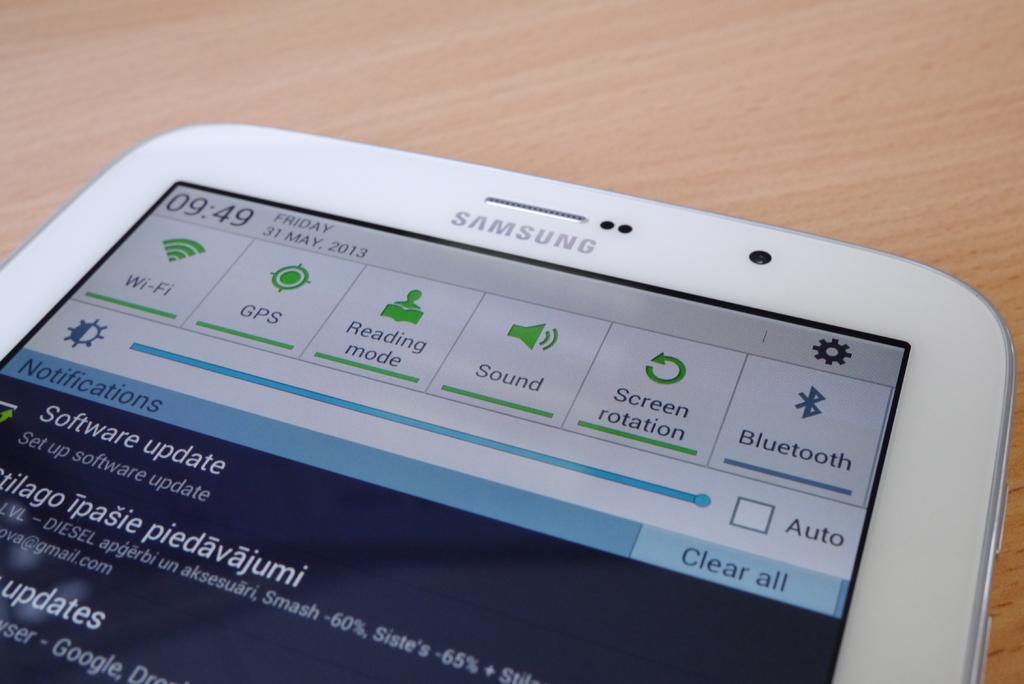What brand is this phone?
Your answer should be very brief. Samsung. What is the brand of the cell phone?
Your answer should be compact. Samsung. 